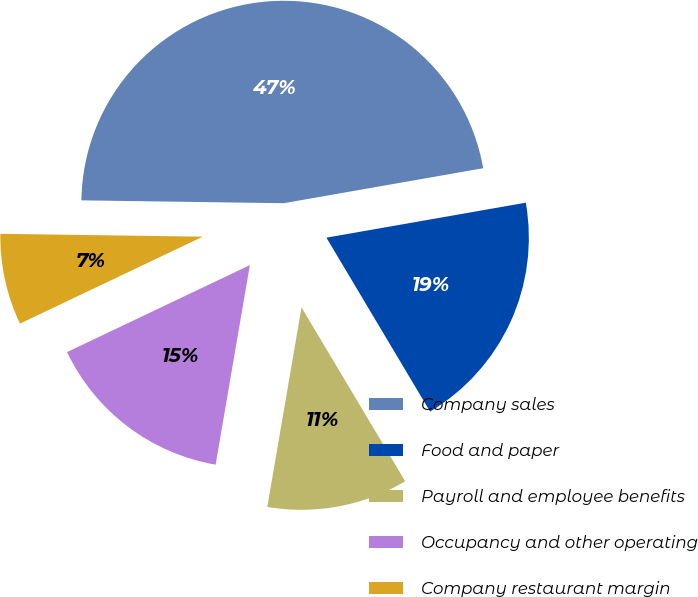<chart> <loc_0><loc_0><loc_500><loc_500><pie_chart><fcel>Company sales<fcel>Food and paper<fcel>Payroll and employee benefits<fcel>Occupancy and other operating<fcel>Company restaurant margin<nl><fcel>47.01%<fcel>19.21%<fcel>11.26%<fcel>15.23%<fcel>7.29%<nl></chart> 